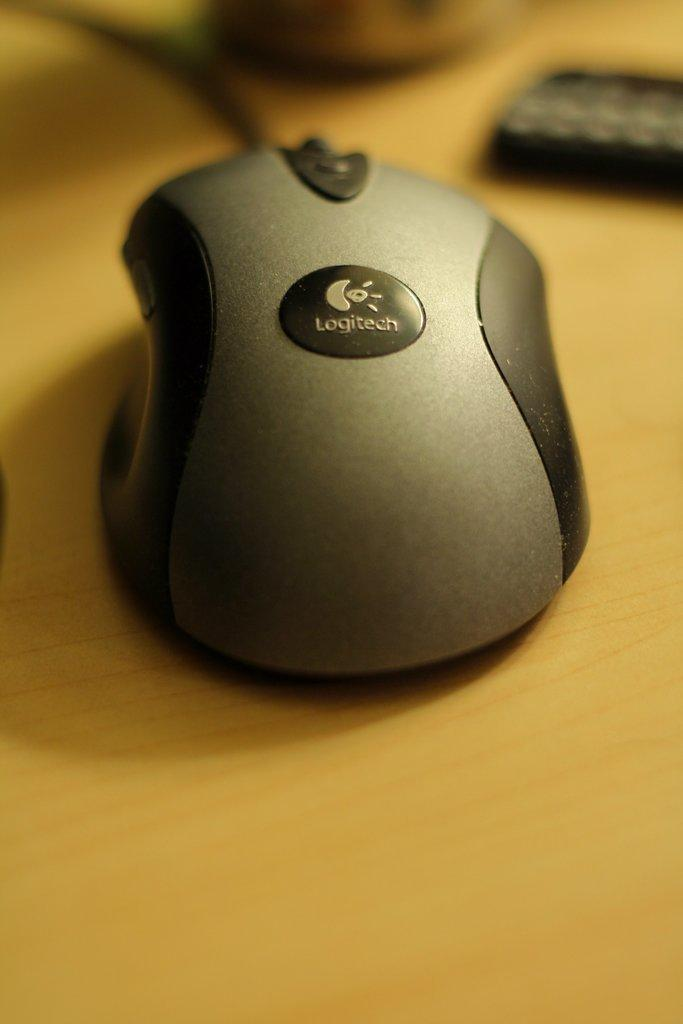What animal is present in the image? There is a mouse in the image. What type of surface is the mouse on? The mouse is on a wooden surface. Can you describe the background of the image? The background of the image is blurry. What else can be seen in the image besides the mouse? There are objects visible in the background. What type of cloth is the mouse using to clean its teeth in the image? There is no cloth or toothbrush present in the image, and the mouse is not shown cleaning its teeth. 